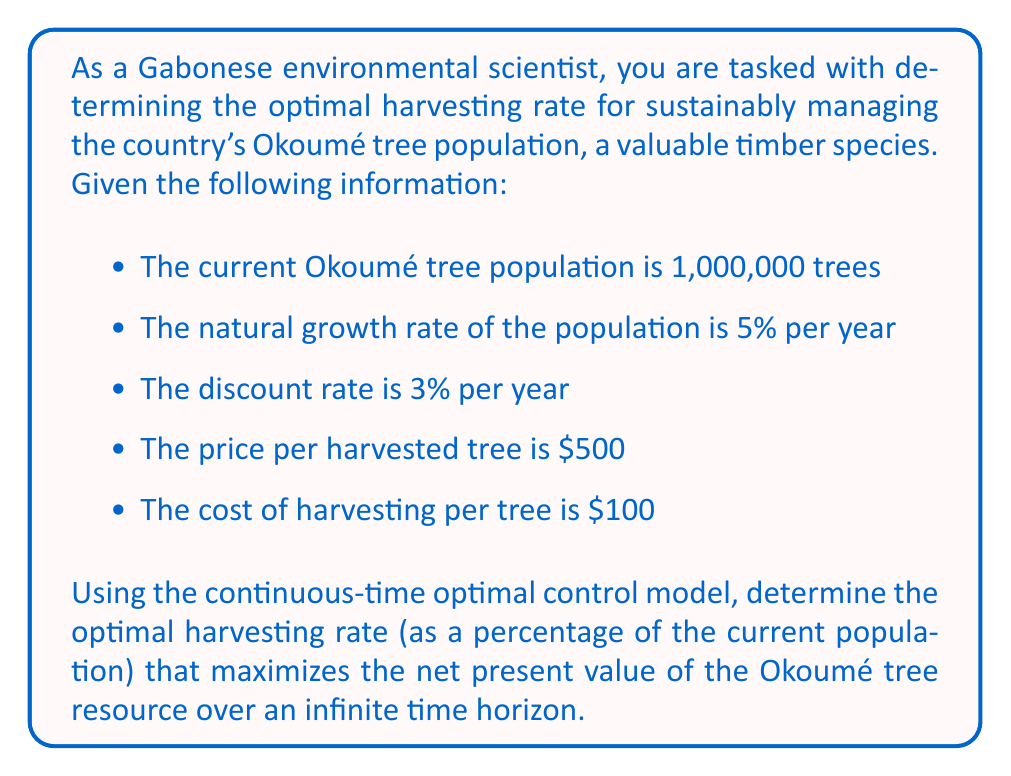Can you solve this math problem? To solve this problem, we'll use the continuous-time optimal control model for renewable resource management. The key steps are:

1) Set up the objective function:
   $$\max_{h(t)} \int_0^{\infty} e^{-\delta t} [p h(t) x(t) - c h(t) x(t)] dt$$
   where $\delta$ is the discount rate, $p$ is the price per unit, $c$ is the cost per unit, $h(t)$ is the harvesting rate, and $x(t)$ is the population size.

2) Define the state equation:
   $$\frac{dx}{dt} = rx(t) - h(t)x(t)$$
   where $r$ is the natural growth rate.

3) Form the current-value Hamiltonian:
   $$H = (p-c)hx + \lambda(rx-hx)$$
   where $\lambda$ is the co-state variable.

4) Apply the maximum principle:
   $$\frac{\partial H}{\partial h} = (p-c)x - \lambda x = 0$$
   $$\frac{\partial H}{\partial x} = (p-c)h + \lambda(r-h) = \delta \lambda - \frac{d\lambda}{dt}$$

5) From the first condition:
   $$\lambda = p-c$$

6) Substitute this into the second condition:
   $$(p-c)h + (p-c)(r-h) = \delta(p-c) - \frac{d\lambda}{dt}$$

7) In steady state, $\frac{d\lambda}{dt} = 0$, so:
   $$(p-c)r = \delta(p-c)$$

8) This simplifies to:
   $$r = \delta$$

9) The optimal harvesting rate is the difference between the natural growth rate and the discount rate:
   $$h^* = r - \delta$$

10) Plug in the given values:
    $$h^* = 0.05 - 0.03 = 0.02 = 2\%$$

Therefore, the optimal harvesting rate is 2% of the current population per year.
Answer: The optimal harvesting rate for the Okoumé tree population is 2% of the current population per year. 